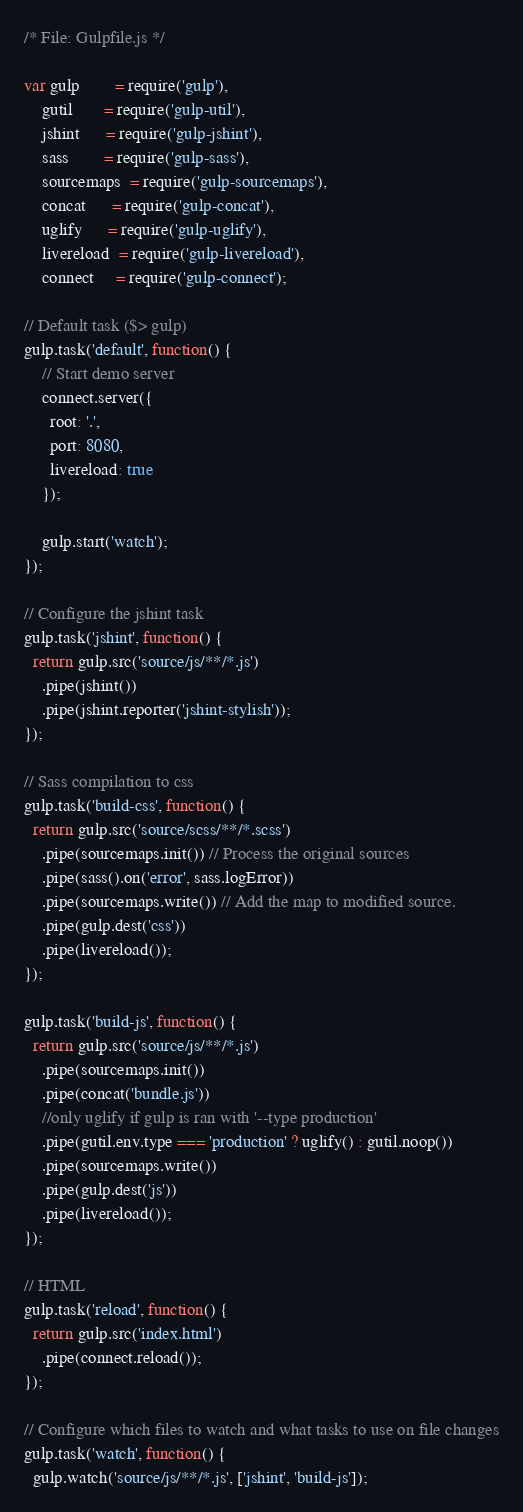<code> <loc_0><loc_0><loc_500><loc_500><_JavaScript_>/* File: Gulpfile.js */

var gulp        = require('gulp'),
    gutil       = require('gulp-util'),
    jshint      = require('gulp-jshint'),
    sass        = require('gulp-sass'),
    sourcemaps  = require('gulp-sourcemaps'),
    concat      = require('gulp-concat'),
    uglify      = require('gulp-uglify'),
    livereload  = require('gulp-livereload'),
    connect     = require('gulp-connect');

// Default task ($> gulp)
gulp.task('default', function() {
    // Start demo server
    connect.server({
      root: '.',
      port: 8080,
      livereload: true
    });

    gulp.start('watch');
});

// Configure the jshint task
gulp.task('jshint', function() {
  return gulp.src('source/js/**/*.js')
    .pipe(jshint())
    .pipe(jshint.reporter('jshint-stylish'));
});

// Sass compilation to css
gulp.task('build-css', function() {
  return gulp.src('source/scss/**/*.scss')
    .pipe(sourcemaps.init()) // Process the original sources
    .pipe(sass().on('error', sass.logError))
    .pipe(sourcemaps.write()) // Add the map to modified source.
    .pipe(gulp.dest('css'))
    .pipe(livereload());
});

gulp.task('build-js', function() {
  return gulp.src('source/js/**/*.js')
    .pipe(sourcemaps.init())
    .pipe(concat('bundle.js'))
    //only uglify if gulp is ran with '--type production'
    .pipe(gutil.env.type === 'production' ? uglify() : gutil.noop())
    .pipe(sourcemaps.write())
    .pipe(gulp.dest('js'))
    .pipe(livereload());
});

// HTML
gulp.task('reload', function() {
  return gulp.src('index.html')
    .pipe(connect.reload());
});

// Configure which files to watch and what tasks to use on file changes
gulp.task('watch', function() {
  gulp.watch('source/js/**/*.js', ['jshint', 'build-js']);</code> 